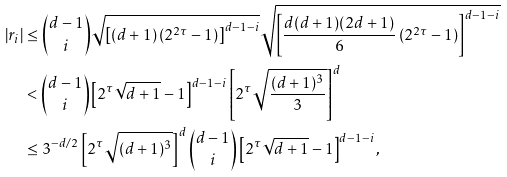<formula> <loc_0><loc_0><loc_500><loc_500>\left | r _ { i } \right | & \leq { d - 1 \choose i } \sqrt { \left [ ( d + 1 ) \left ( 2 ^ { 2 \tau } - 1 \right ) \right ] ^ { d - 1 - i } } \sqrt { \left [ \frac { d ( d + 1 ) ( 2 d + 1 ) } { 6 } \left ( 2 ^ { 2 \tau } - 1 \right ) \right ] ^ { d - 1 - i } } \\ & < { d - 1 \choose i } \left [ 2 ^ { \tau } \sqrt { d + 1 } - 1 \right ] ^ { d - 1 - i } \left [ 2 ^ { \tau } \sqrt { \frac { ( d + 1 ) ^ { 3 } } { 3 } } \right ] ^ { d } \\ & \leq 3 ^ { - d / 2 } \left [ 2 ^ { \tau } \sqrt { ( d + 1 ) ^ { 3 } } \right ] ^ { d } { d - 1 \choose i } \left [ 2 ^ { \tau } \sqrt { d + 1 } - 1 \right ] ^ { d - 1 - i } ,</formula> 